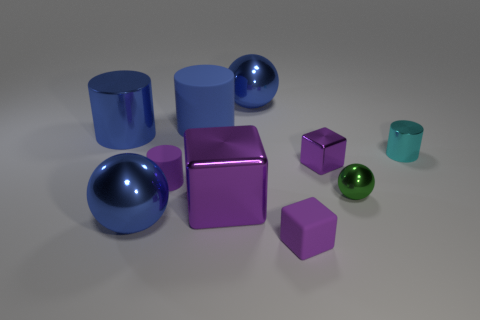Subtract all big blue matte cylinders. How many cylinders are left? 3 Subtract all cylinders. How many objects are left? 6 Subtract 1 blocks. How many blocks are left? 2 Subtract all blue balls. How many balls are left? 1 Subtract all brown spheres. Subtract all blue cubes. How many spheres are left? 3 Subtract all gray cubes. How many green spheres are left? 1 Subtract all tiny green metallic balls. Subtract all tiny purple metallic cubes. How many objects are left? 8 Add 9 small cyan metallic cylinders. How many small cyan metallic cylinders are left? 10 Add 3 tiny blue rubber cylinders. How many tiny blue rubber cylinders exist? 3 Subtract 0 cyan spheres. How many objects are left? 10 